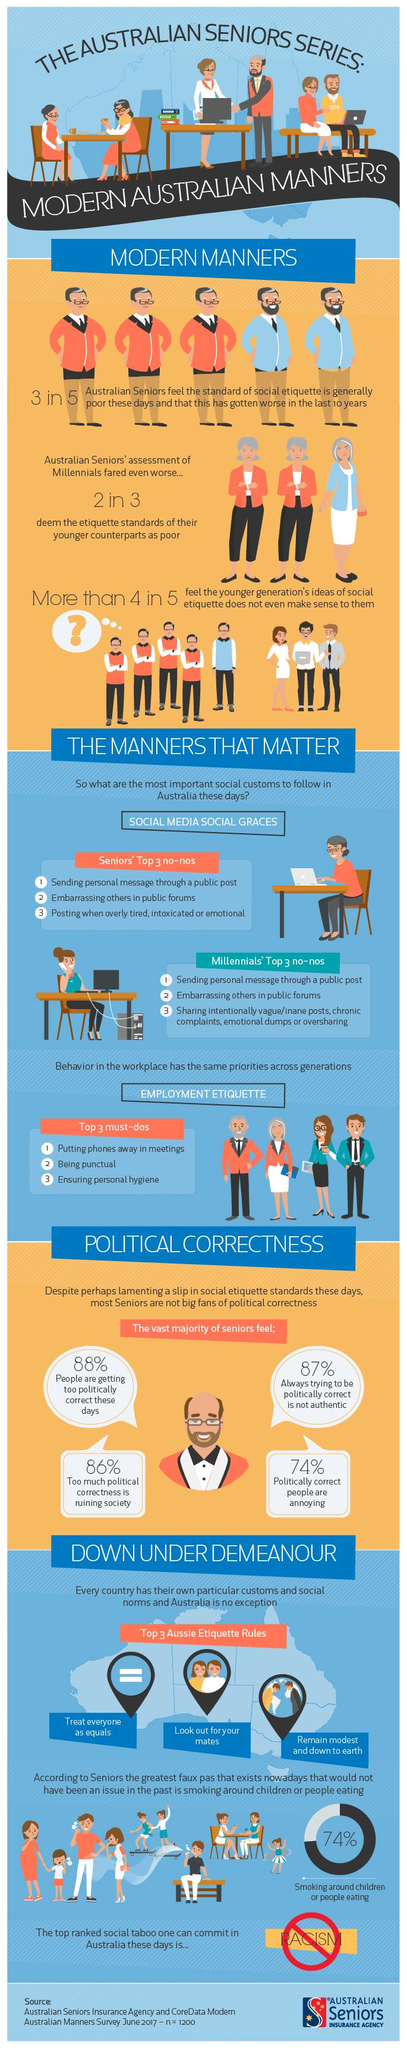Point out several critical features in this image. A survey found that 74% of Australian seniors believe that politically correct people are annoying. According to a recent survey, a staggering 86% of Australian seniors believe that political correctness is ruining society. 